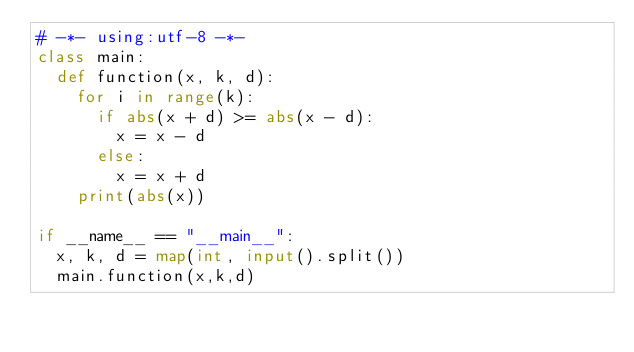Convert code to text. <code><loc_0><loc_0><loc_500><loc_500><_Python_># -*- using:utf-8 -*-
class main:
  def function(x, k, d):
    for i in range(k):
      if abs(x + d) >= abs(x - d):
        x = x - d
      else:
        x = x + d
    print(abs(x))

if __name__ == "__main__":
  x, k, d = map(int, input().split())
  main.function(x,k,d)</code> 